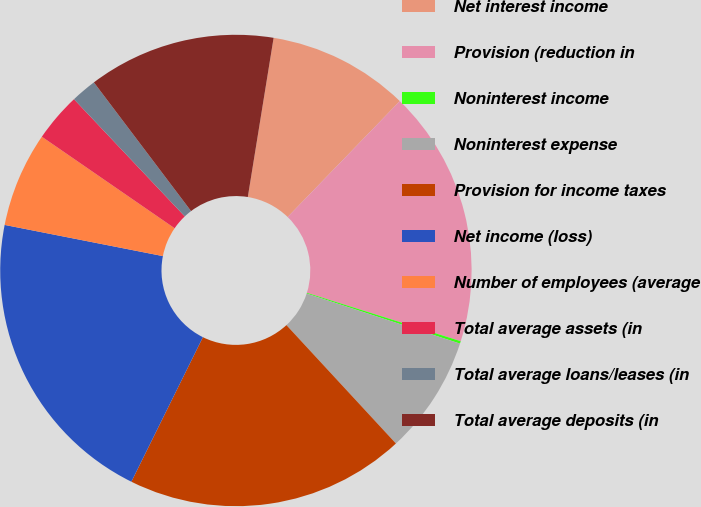Convert chart. <chart><loc_0><loc_0><loc_500><loc_500><pie_chart><fcel>Net interest income<fcel>Provision (reduction in<fcel>Noninterest income<fcel>Noninterest expense<fcel>Provision for income taxes<fcel>Net income (loss)<fcel>Number of employees (average<fcel>Total average assets (in<fcel>Total average loans/leases (in<fcel>Total average deposits (in<nl><fcel>9.68%<fcel>17.61%<fcel>0.17%<fcel>8.1%<fcel>19.19%<fcel>20.78%<fcel>6.51%<fcel>3.34%<fcel>1.76%<fcel>12.85%<nl></chart> 